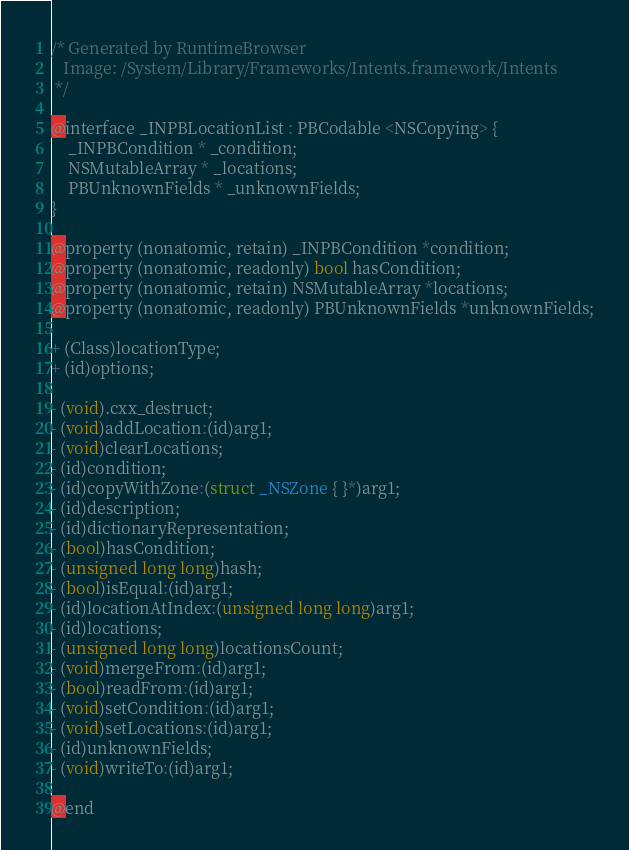<code> <loc_0><loc_0><loc_500><loc_500><_C_>/* Generated by RuntimeBrowser
   Image: /System/Library/Frameworks/Intents.framework/Intents
 */

@interface _INPBLocationList : PBCodable <NSCopying> {
    _INPBCondition * _condition;
    NSMutableArray * _locations;
    PBUnknownFields * _unknownFields;
}

@property (nonatomic, retain) _INPBCondition *condition;
@property (nonatomic, readonly) bool hasCondition;
@property (nonatomic, retain) NSMutableArray *locations;
@property (nonatomic, readonly) PBUnknownFields *unknownFields;

+ (Class)locationType;
+ (id)options;

- (void).cxx_destruct;
- (void)addLocation:(id)arg1;
- (void)clearLocations;
- (id)condition;
- (id)copyWithZone:(struct _NSZone { }*)arg1;
- (id)description;
- (id)dictionaryRepresentation;
- (bool)hasCondition;
- (unsigned long long)hash;
- (bool)isEqual:(id)arg1;
- (id)locationAtIndex:(unsigned long long)arg1;
- (id)locations;
- (unsigned long long)locationsCount;
- (void)mergeFrom:(id)arg1;
- (bool)readFrom:(id)arg1;
- (void)setCondition:(id)arg1;
- (void)setLocations:(id)arg1;
- (id)unknownFields;
- (void)writeTo:(id)arg1;

@end
</code> 